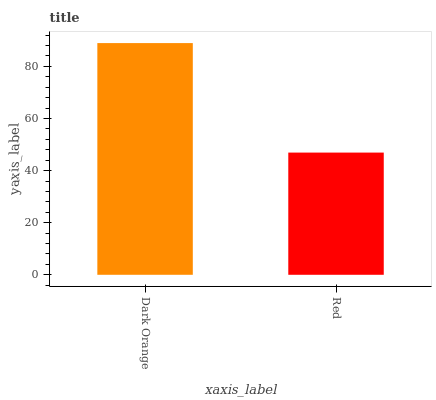Is Red the minimum?
Answer yes or no. Yes. Is Dark Orange the maximum?
Answer yes or no. Yes. Is Red the maximum?
Answer yes or no. No. Is Dark Orange greater than Red?
Answer yes or no. Yes. Is Red less than Dark Orange?
Answer yes or no. Yes. Is Red greater than Dark Orange?
Answer yes or no. No. Is Dark Orange less than Red?
Answer yes or no. No. Is Dark Orange the high median?
Answer yes or no. Yes. Is Red the low median?
Answer yes or no. Yes. Is Red the high median?
Answer yes or no. No. Is Dark Orange the low median?
Answer yes or no. No. 